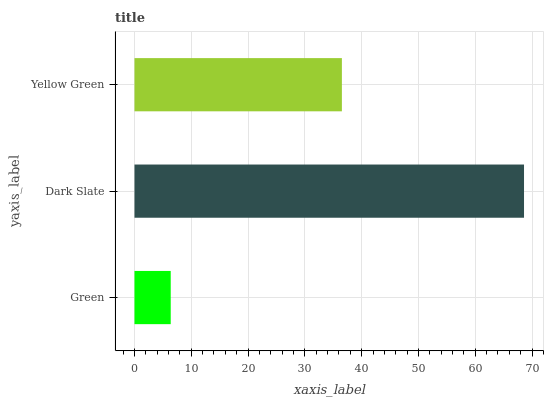Is Green the minimum?
Answer yes or no. Yes. Is Dark Slate the maximum?
Answer yes or no. Yes. Is Yellow Green the minimum?
Answer yes or no. No. Is Yellow Green the maximum?
Answer yes or no. No. Is Dark Slate greater than Yellow Green?
Answer yes or no. Yes. Is Yellow Green less than Dark Slate?
Answer yes or no. Yes. Is Yellow Green greater than Dark Slate?
Answer yes or no. No. Is Dark Slate less than Yellow Green?
Answer yes or no. No. Is Yellow Green the high median?
Answer yes or no. Yes. Is Yellow Green the low median?
Answer yes or no. Yes. Is Green the high median?
Answer yes or no. No. Is Dark Slate the low median?
Answer yes or no. No. 